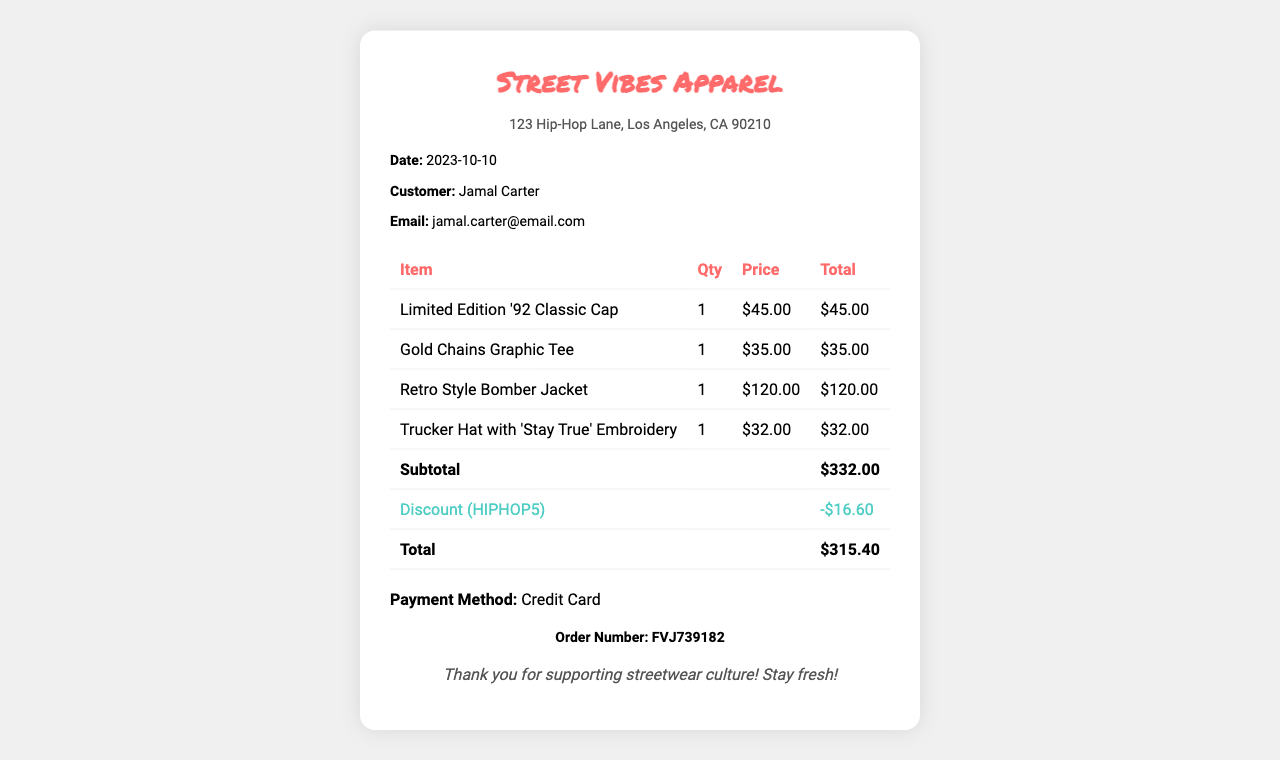What is the name of the store? The name of the store is provided at the top of the receipt, which is recognizable to customers.
Answer: Street Vibes Apparel What is the date of the purchase? The date of the purchase can be found in the customer info section of the receipt, indicating when the transaction occurred.
Answer: 2023-10-10 Who is the customer? The customer's name is clearly stated in the receipt, reflecting the person who made the purchase.
Answer: Jamal Carter What is the email address of the customer? The receipt displays an email address linked to the customer's account or contact for further communication.
Answer: jamal.carter@email.com What was the discount code used? The discount code is mentioned in the itemized costs section, giving information about any promotions applied during checkout.
Answer: HIPHOP5 What is the subtotal amount? The subtotal amount represents the total price of the items before any discounts are applied, providing insight into the initial cost.
Answer: $332.00 How much was the discount? The document specifies the amount deducted from the subtotal due to the discount code, which is important for understanding savings.
Answer: -$16.60 What is the total amount after the discount? The total amount shows the final cost after applying the discount, showing the total the customer needs to pay.
Answer: $315.40 What payment method was used? The payment method section clarifies how the customer completed the transaction, which is relevant for payment records.
Answer: Credit Card What is the order number? The order number serves as a unique identifier for the transaction, which can be referenced for inquiries or returns.
Answer: FVJ739182 